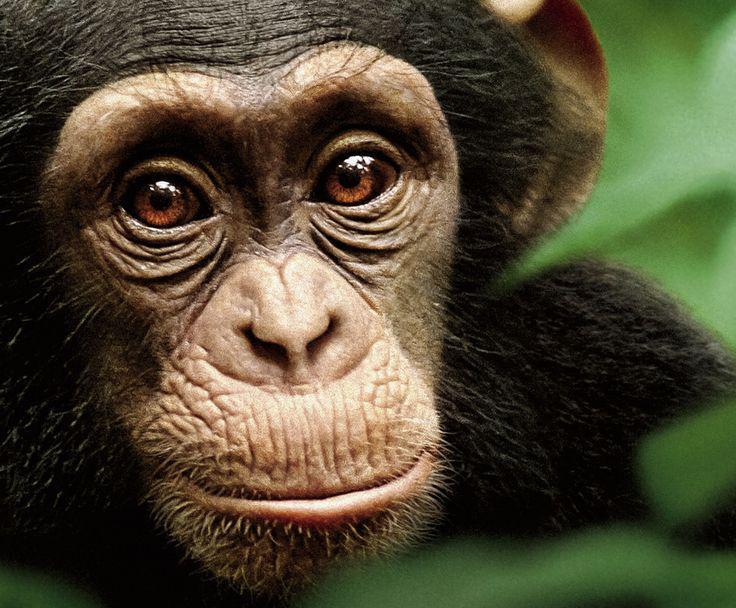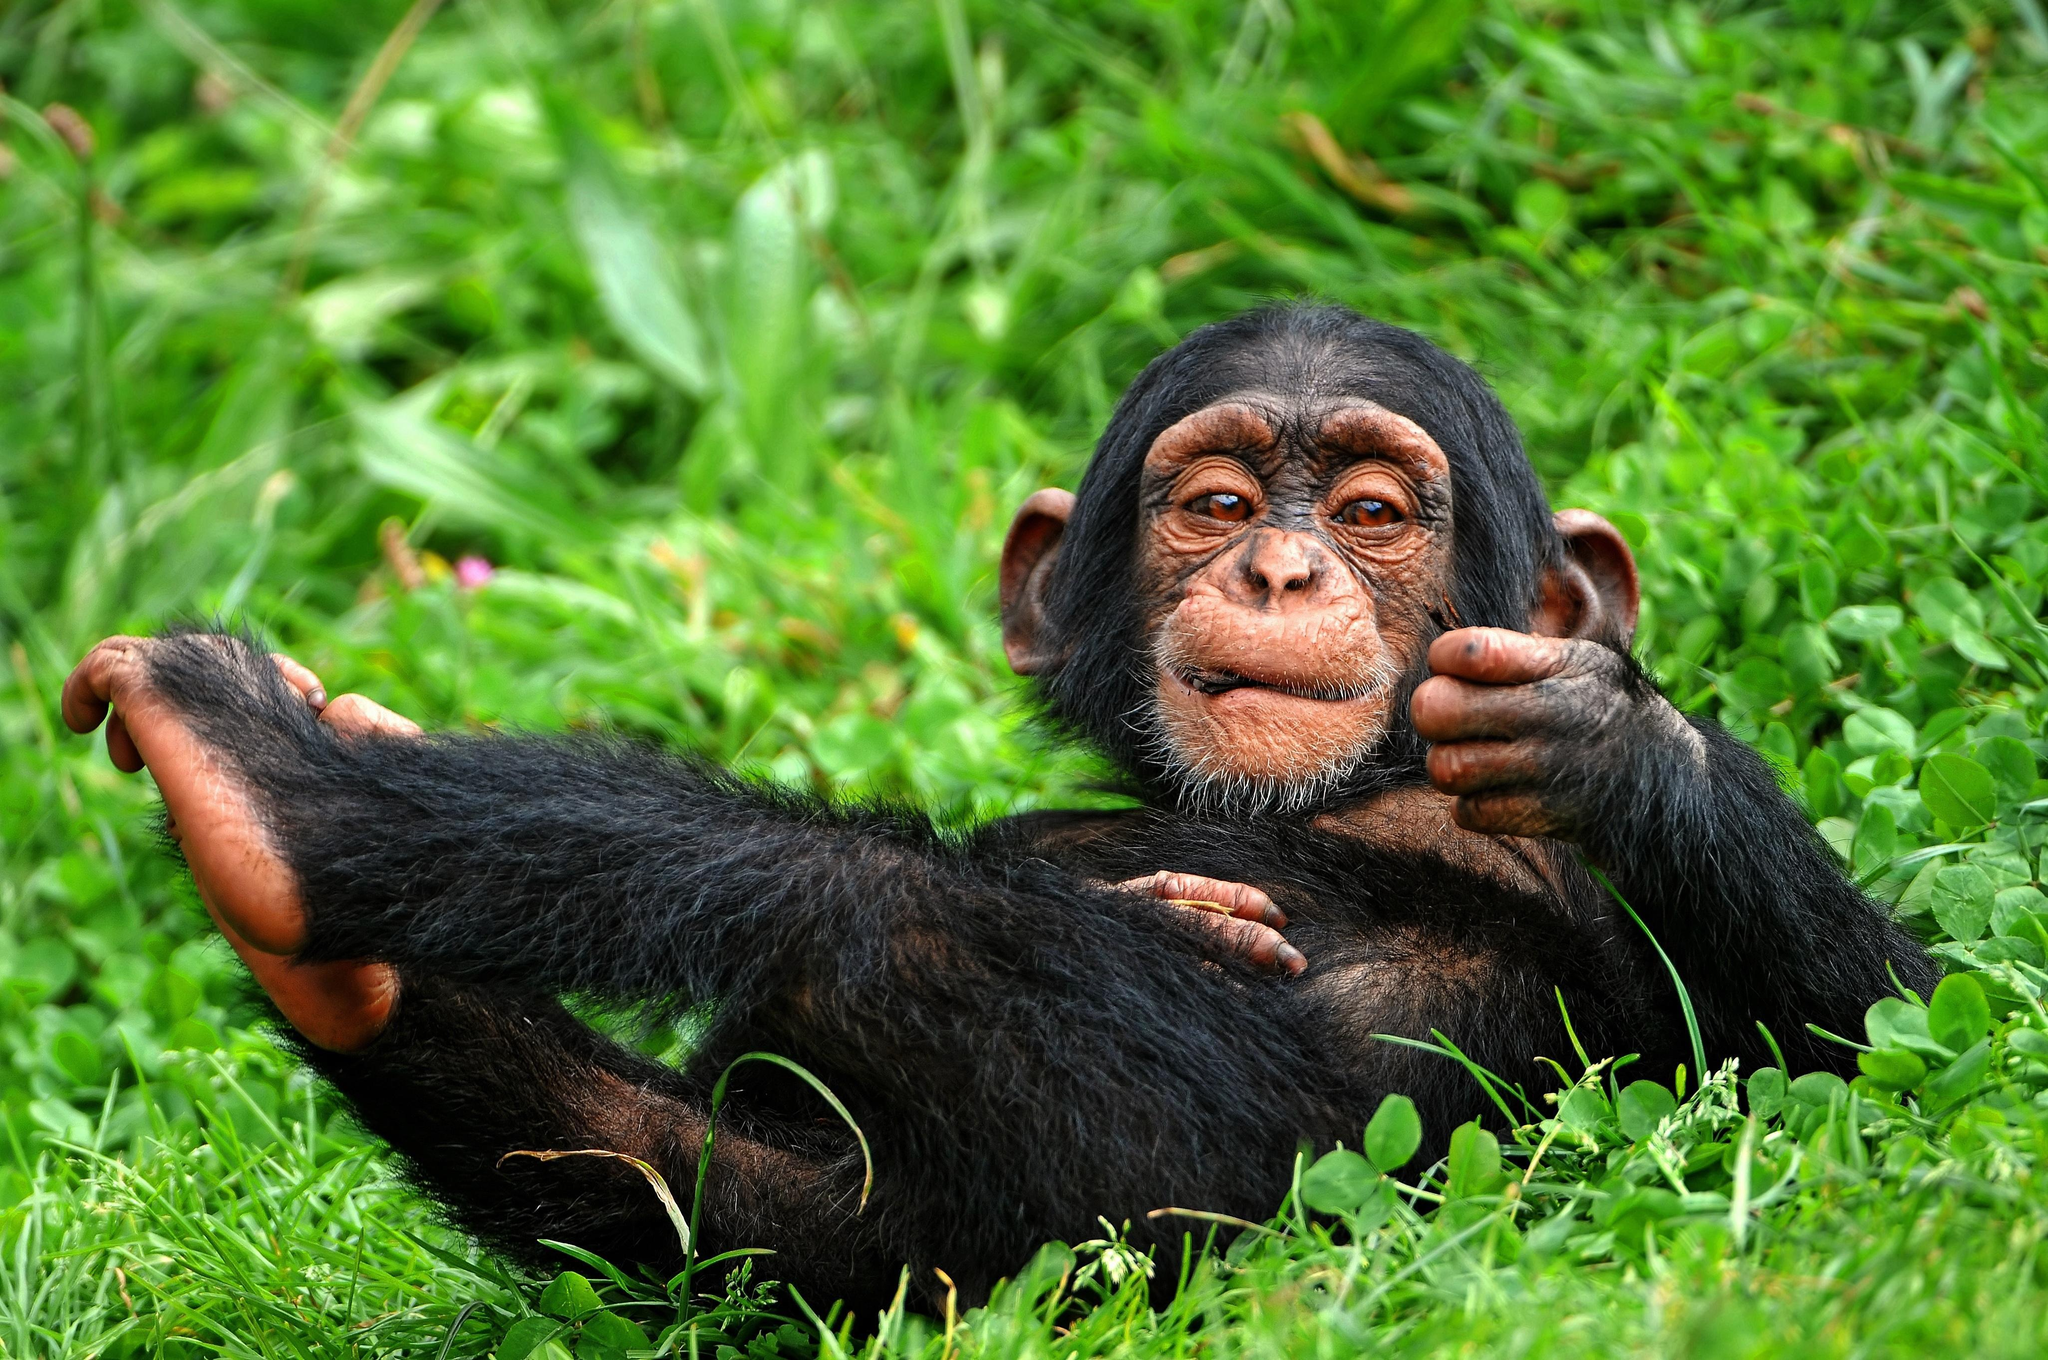The first image is the image on the left, the second image is the image on the right. Evaluate the accuracy of this statement regarding the images: "There are only two monkeys.". Is it true? Answer yes or no. Yes. The first image is the image on the left, the second image is the image on the right. For the images shown, is this caption "One of the image features more than one monkey." true? Answer yes or no. No. 